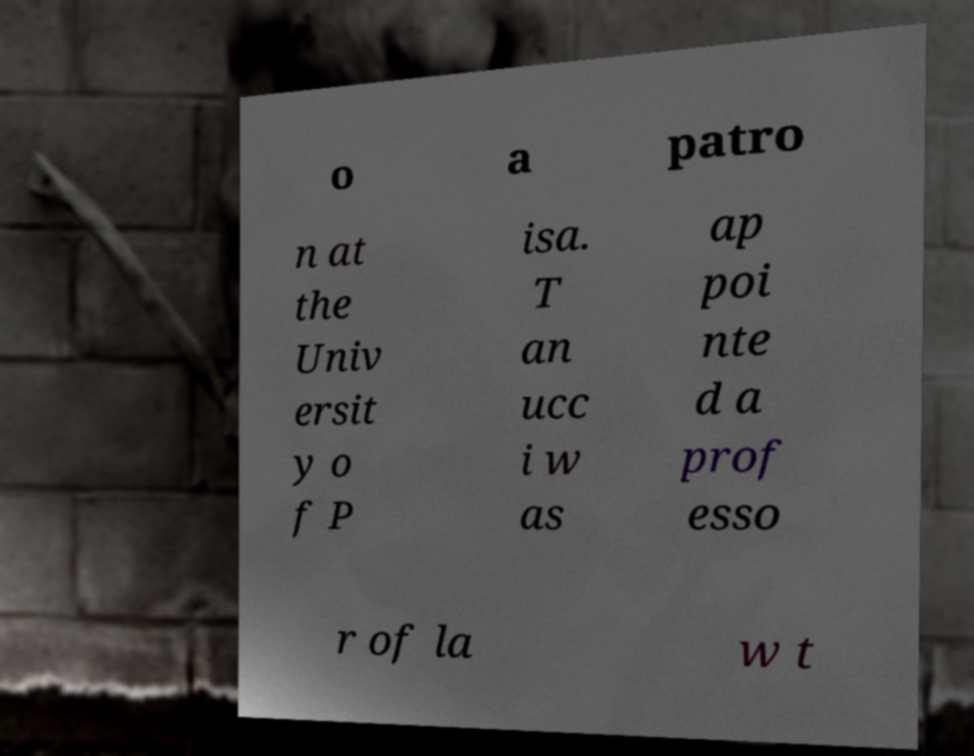Can you accurately transcribe the text from the provided image for me? o a patro n at the Univ ersit y o f P isa. T an ucc i w as ap poi nte d a prof esso r of la w t 